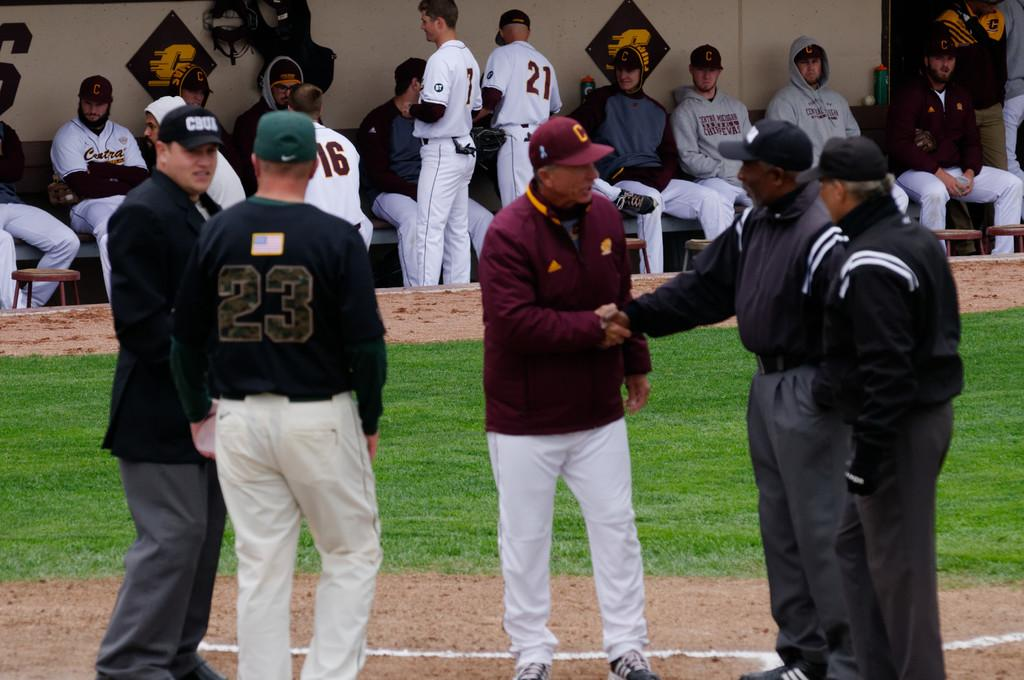<image>
Present a compact description of the photo's key features. As officials confer on the mound, players wearing 21, 16 and other numbers converse in the dugout. 